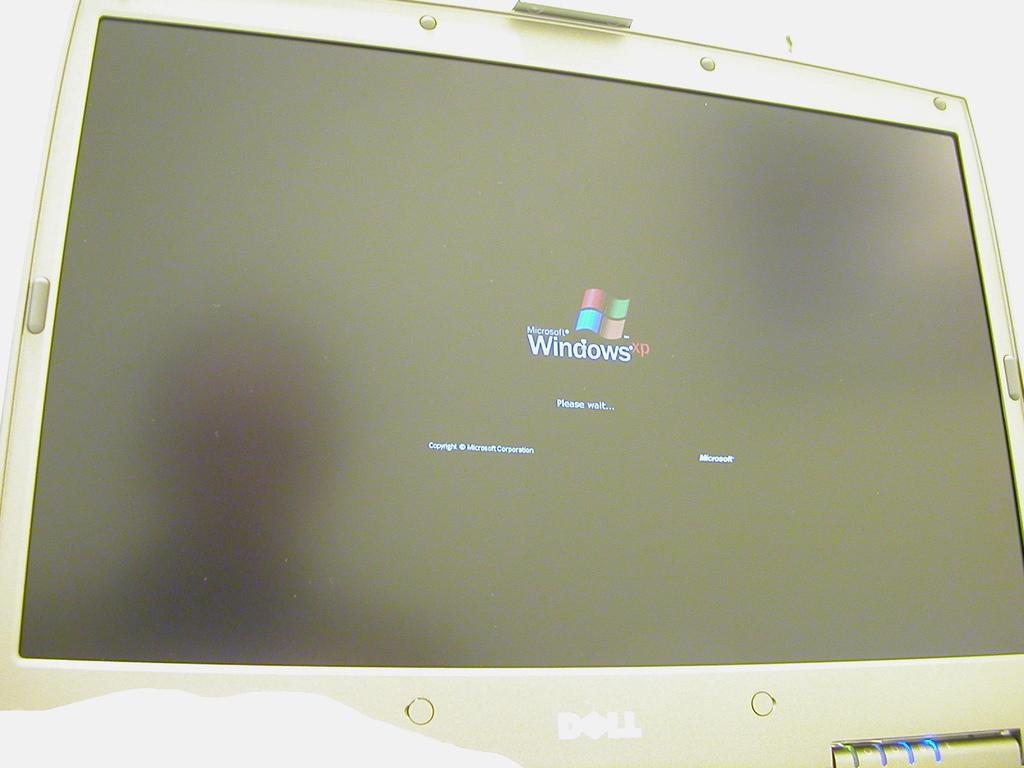Provide a one-sentence caption for the provided image. A Windows start screen on a white computer monitor. 